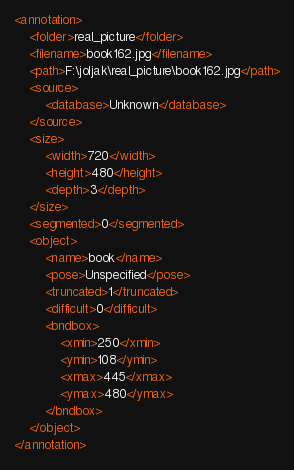<code> <loc_0><loc_0><loc_500><loc_500><_XML_><annotation>
	<folder>real_picture</folder>
	<filename>book162.jpg</filename>
	<path>F:\joljak\real_picture\book162.jpg</path>
	<source>
		<database>Unknown</database>
	</source>
	<size>
		<width>720</width>
		<height>480</height>
		<depth>3</depth>
	</size>
	<segmented>0</segmented>
	<object>
		<name>book</name>
		<pose>Unspecified</pose>
		<truncated>1</truncated>
		<difficult>0</difficult>
		<bndbox>
			<xmin>250</xmin>
			<ymin>108</ymin>
			<xmax>445</xmax>
			<ymax>480</ymax>
		</bndbox>
	</object>
</annotation>
</code> 